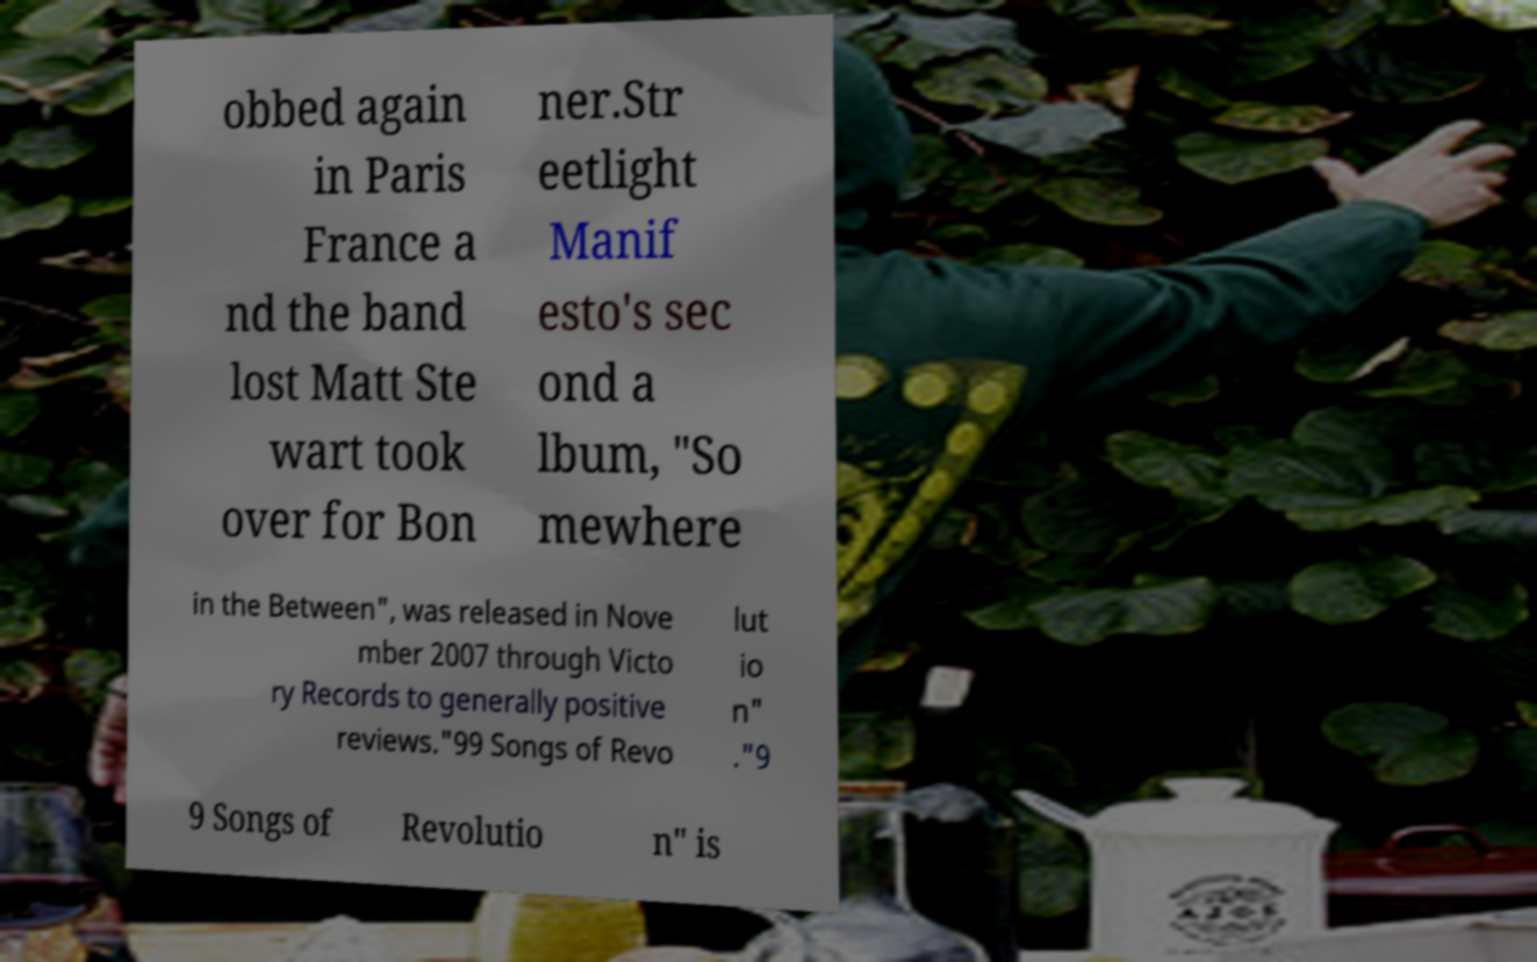There's text embedded in this image that I need extracted. Can you transcribe it verbatim? obbed again in Paris France a nd the band lost Matt Ste wart took over for Bon ner.Str eetlight Manif esto's sec ond a lbum, "So mewhere in the Between", was released in Nove mber 2007 through Victo ry Records to generally positive reviews."99 Songs of Revo lut io n" ."9 9 Songs of Revolutio n" is 